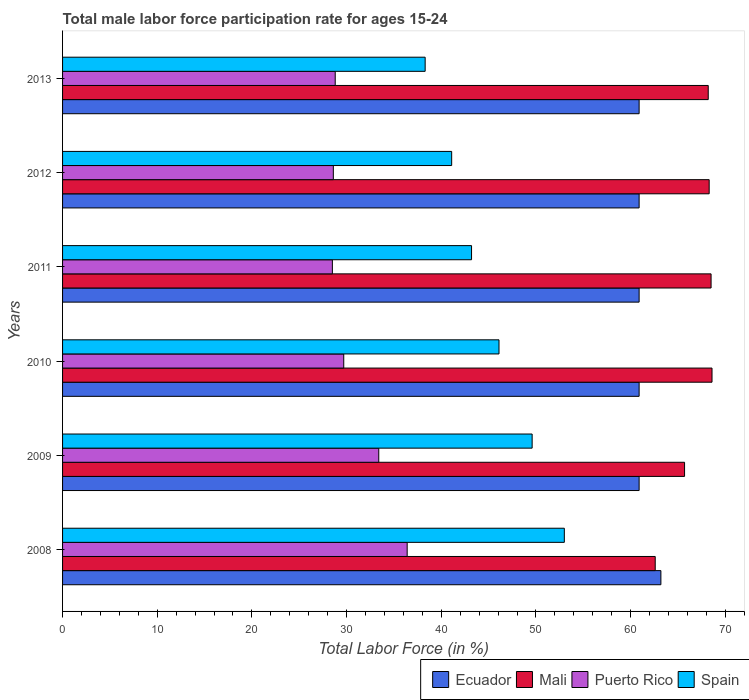How many different coloured bars are there?
Make the answer very short. 4. What is the male labor force participation rate in Spain in 2010?
Your answer should be very brief. 46.1. Across all years, what is the maximum male labor force participation rate in Ecuador?
Make the answer very short. 63.2. Across all years, what is the minimum male labor force participation rate in Ecuador?
Keep it short and to the point. 60.9. In which year was the male labor force participation rate in Mali minimum?
Keep it short and to the point. 2008. What is the total male labor force participation rate in Mali in the graph?
Your answer should be very brief. 401.9. What is the difference between the male labor force participation rate in Mali in 2012 and that in 2013?
Offer a terse response. 0.1. What is the difference between the male labor force participation rate in Puerto Rico in 2009 and the male labor force participation rate in Mali in 2012?
Your answer should be compact. -34.9. What is the average male labor force participation rate in Ecuador per year?
Give a very brief answer. 61.28. In the year 2013, what is the difference between the male labor force participation rate in Puerto Rico and male labor force participation rate in Mali?
Your answer should be compact. -39.4. In how many years, is the male labor force participation rate in Spain greater than 20 %?
Ensure brevity in your answer.  6. What is the ratio of the male labor force participation rate in Spain in 2008 to that in 2013?
Provide a succinct answer. 1.38. Is the difference between the male labor force participation rate in Puerto Rico in 2011 and 2012 greater than the difference between the male labor force participation rate in Mali in 2011 and 2012?
Offer a terse response. No. What is the difference between the highest and the second highest male labor force participation rate in Ecuador?
Provide a short and direct response. 2.3. What is the difference between the highest and the lowest male labor force participation rate in Mali?
Ensure brevity in your answer.  6. In how many years, is the male labor force participation rate in Spain greater than the average male labor force participation rate in Spain taken over all years?
Your response must be concise. 3. Is the sum of the male labor force participation rate in Spain in 2011 and 2013 greater than the maximum male labor force participation rate in Puerto Rico across all years?
Your response must be concise. Yes. What does the 2nd bar from the top in 2013 represents?
Make the answer very short. Puerto Rico. What does the 3rd bar from the bottom in 2010 represents?
Your answer should be very brief. Puerto Rico. How many bars are there?
Your answer should be compact. 24. How many years are there in the graph?
Keep it short and to the point. 6. Are the values on the major ticks of X-axis written in scientific E-notation?
Ensure brevity in your answer.  No. Does the graph contain any zero values?
Your answer should be very brief. No. Where does the legend appear in the graph?
Ensure brevity in your answer.  Bottom right. How many legend labels are there?
Your response must be concise. 4. How are the legend labels stacked?
Give a very brief answer. Horizontal. What is the title of the graph?
Offer a very short reply. Total male labor force participation rate for ages 15-24. What is the label or title of the X-axis?
Make the answer very short. Total Labor Force (in %). What is the label or title of the Y-axis?
Provide a succinct answer. Years. What is the Total Labor Force (in %) in Ecuador in 2008?
Your answer should be very brief. 63.2. What is the Total Labor Force (in %) in Mali in 2008?
Offer a very short reply. 62.6. What is the Total Labor Force (in %) in Puerto Rico in 2008?
Offer a very short reply. 36.4. What is the Total Labor Force (in %) of Ecuador in 2009?
Make the answer very short. 60.9. What is the Total Labor Force (in %) of Mali in 2009?
Your answer should be compact. 65.7. What is the Total Labor Force (in %) of Puerto Rico in 2009?
Offer a very short reply. 33.4. What is the Total Labor Force (in %) in Spain in 2009?
Your response must be concise. 49.6. What is the Total Labor Force (in %) in Ecuador in 2010?
Offer a very short reply. 60.9. What is the Total Labor Force (in %) of Mali in 2010?
Give a very brief answer. 68.6. What is the Total Labor Force (in %) in Puerto Rico in 2010?
Keep it short and to the point. 29.7. What is the Total Labor Force (in %) of Spain in 2010?
Provide a short and direct response. 46.1. What is the Total Labor Force (in %) of Ecuador in 2011?
Give a very brief answer. 60.9. What is the Total Labor Force (in %) in Mali in 2011?
Make the answer very short. 68.5. What is the Total Labor Force (in %) of Spain in 2011?
Provide a succinct answer. 43.2. What is the Total Labor Force (in %) in Ecuador in 2012?
Provide a short and direct response. 60.9. What is the Total Labor Force (in %) in Mali in 2012?
Make the answer very short. 68.3. What is the Total Labor Force (in %) in Puerto Rico in 2012?
Offer a terse response. 28.6. What is the Total Labor Force (in %) of Spain in 2012?
Offer a terse response. 41.1. What is the Total Labor Force (in %) in Ecuador in 2013?
Keep it short and to the point. 60.9. What is the Total Labor Force (in %) of Mali in 2013?
Provide a succinct answer. 68.2. What is the Total Labor Force (in %) in Puerto Rico in 2013?
Offer a very short reply. 28.8. What is the Total Labor Force (in %) in Spain in 2013?
Offer a terse response. 38.3. Across all years, what is the maximum Total Labor Force (in %) in Ecuador?
Keep it short and to the point. 63.2. Across all years, what is the maximum Total Labor Force (in %) of Mali?
Your answer should be compact. 68.6. Across all years, what is the maximum Total Labor Force (in %) of Puerto Rico?
Your response must be concise. 36.4. Across all years, what is the minimum Total Labor Force (in %) in Ecuador?
Give a very brief answer. 60.9. Across all years, what is the minimum Total Labor Force (in %) of Mali?
Offer a terse response. 62.6. Across all years, what is the minimum Total Labor Force (in %) of Spain?
Make the answer very short. 38.3. What is the total Total Labor Force (in %) in Ecuador in the graph?
Offer a very short reply. 367.7. What is the total Total Labor Force (in %) in Mali in the graph?
Provide a short and direct response. 401.9. What is the total Total Labor Force (in %) in Puerto Rico in the graph?
Provide a short and direct response. 185.4. What is the total Total Labor Force (in %) of Spain in the graph?
Make the answer very short. 271.3. What is the difference between the Total Labor Force (in %) of Ecuador in 2008 and that in 2009?
Ensure brevity in your answer.  2.3. What is the difference between the Total Labor Force (in %) of Spain in 2008 and that in 2009?
Keep it short and to the point. 3.4. What is the difference between the Total Labor Force (in %) of Puerto Rico in 2008 and that in 2010?
Your response must be concise. 6.7. What is the difference between the Total Labor Force (in %) of Spain in 2008 and that in 2010?
Your answer should be very brief. 6.9. What is the difference between the Total Labor Force (in %) in Puerto Rico in 2008 and that in 2011?
Offer a terse response. 7.9. What is the difference between the Total Labor Force (in %) in Spain in 2008 and that in 2011?
Offer a terse response. 9.8. What is the difference between the Total Labor Force (in %) of Spain in 2008 and that in 2012?
Your answer should be compact. 11.9. What is the difference between the Total Labor Force (in %) in Ecuador in 2008 and that in 2013?
Offer a terse response. 2.3. What is the difference between the Total Labor Force (in %) of Mali in 2008 and that in 2013?
Provide a short and direct response. -5.6. What is the difference between the Total Labor Force (in %) in Spain in 2008 and that in 2013?
Your response must be concise. 14.7. What is the difference between the Total Labor Force (in %) in Puerto Rico in 2009 and that in 2010?
Ensure brevity in your answer.  3.7. What is the difference between the Total Labor Force (in %) in Ecuador in 2009 and that in 2011?
Ensure brevity in your answer.  0. What is the difference between the Total Labor Force (in %) of Puerto Rico in 2009 and that in 2011?
Your answer should be very brief. 4.9. What is the difference between the Total Labor Force (in %) in Spain in 2009 and that in 2011?
Make the answer very short. 6.4. What is the difference between the Total Labor Force (in %) in Mali in 2009 and that in 2012?
Your answer should be compact. -2.6. What is the difference between the Total Labor Force (in %) of Puerto Rico in 2009 and that in 2012?
Offer a terse response. 4.8. What is the difference between the Total Labor Force (in %) in Ecuador in 2010 and that in 2011?
Your response must be concise. 0. What is the difference between the Total Labor Force (in %) in Ecuador in 2010 and that in 2012?
Make the answer very short. 0. What is the difference between the Total Labor Force (in %) in Mali in 2010 and that in 2012?
Make the answer very short. 0.3. What is the difference between the Total Labor Force (in %) in Spain in 2010 and that in 2012?
Keep it short and to the point. 5. What is the difference between the Total Labor Force (in %) of Mali in 2010 and that in 2013?
Keep it short and to the point. 0.4. What is the difference between the Total Labor Force (in %) of Spain in 2010 and that in 2013?
Your answer should be very brief. 7.8. What is the difference between the Total Labor Force (in %) of Ecuador in 2011 and that in 2012?
Ensure brevity in your answer.  0. What is the difference between the Total Labor Force (in %) in Mali in 2011 and that in 2012?
Offer a terse response. 0.2. What is the difference between the Total Labor Force (in %) in Puerto Rico in 2011 and that in 2012?
Offer a very short reply. -0.1. What is the difference between the Total Labor Force (in %) of Puerto Rico in 2011 and that in 2013?
Provide a short and direct response. -0.3. What is the difference between the Total Labor Force (in %) of Mali in 2012 and that in 2013?
Provide a short and direct response. 0.1. What is the difference between the Total Labor Force (in %) of Puerto Rico in 2012 and that in 2013?
Keep it short and to the point. -0.2. What is the difference between the Total Labor Force (in %) of Spain in 2012 and that in 2013?
Your answer should be compact. 2.8. What is the difference between the Total Labor Force (in %) in Ecuador in 2008 and the Total Labor Force (in %) in Puerto Rico in 2009?
Your response must be concise. 29.8. What is the difference between the Total Labor Force (in %) of Ecuador in 2008 and the Total Labor Force (in %) of Spain in 2009?
Provide a short and direct response. 13.6. What is the difference between the Total Labor Force (in %) in Mali in 2008 and the Total Labor Force (in %) in Puerto Rico in 2009?
Provide a succinct answer. 29.2. What is the difference between the Total Labor Force (in %) of Mali in 2008 and the Total Labor Force (in %) of Spain in 2009?
Provide a succinct answer. 13. What is the difference between the Total Labor Force (in %) of Ecuador in 2008 and the Total Labor Force (in %) of Puerto Rico in 2010?
Provide a succinct answer. 33.5. What is the difference between the Total Labor Force (in %) in Ecuador in 2008 and the Total Labor Force (in %) in Spain in 2010?
Offer a very short reply. 17.1. What is the difference between the Total Labor Force (in %) in Mali in 2008 and the Total Labor Force (in %) in Puerto Rico in 2010?
Offer a terse response. 32.9. What is the difference between the Total Labor Force (in %) in Mali in 2008 and the Total Labor Force (in %) in Spain in 2010?
Your response must be concise. 16.5. What is the difference between the Total Labor Force (in %) of Ecuador in 2008 and the Total Labor Force (in %) of Mali in 2011?
Your response must be concise. -5.3. What is the difference between the Total Labor Force (in %) in Ecuador in 2008 and the Total Labor Force (in %) in Puerto Rico in 2011?
Your response must be concise. 34.7. What is the difference between the Total Labor Force (in %) of Mali in 2008 and the Total Labor Force (in %) of Puerto Rico in 2011?
Your answer should be very brief. 34.1. What is the difference between the Total Labor Force (in %) of Mali in 2008 and the Total Labor Force (in %) of Spain in 2011?
Give a very brief answer. 19.4. What is the difference between the Total Labor Force (in %) of Ecuador in 2008 and the Total Labor Force (in %) of Puerto Rico in 2012?
Your answer should be compact. 34.6. What is the difference between the Total Labor Force (in %) in Ecuador in 2008 and the Total Labor Force (in %) in Spain in 2012?
Make the answer very short. 22.1. What is the difference between the Total Labor Force (in %) of Ecuador in 2008 and the Total Labor Force (in %) of Mali in 2013?
Your answer should be compact. -5. What is the difference between the Total Labor Force (in %) in Ecuador in 2008 and the Total Labor Force (in %) in Puerto Rico in 2013?
Make the answer very short. 34.4. What is the difference between the Total Labor Force (in %) in Ecuador in 2008 and the Total Labor Force (in %) in Spain in 2013?
Offer a terse response. 24.9. What is the difference between the Total Labor Force (in %) of Mali in 2008 and the Total Labor Force (in %) of Puerto Rico in 2013?
Provide a succinct answer. 33.8. What is the difference between the Total Labor Force (in %) in Mali in 2008 and the Total Labor Force (in %) in Spain in 2013?
Make the answer very short. 24.3. What is the difference between the Total Labor Force (in %) in Puerto Rico in 2008 and the Total Labor Force (in %) in Spain in 2013?
Give a very brief answer. -1.9. What is the difference between the Total Labor Force (in %) of Ecuador in 2009 and the Total Labor Force (in %) of Mali in 2010?
Give a very brief answer. -7.7. What is the difference between the Total Labor Force (in %) of Ecuador in 2009 and the Total Labor Force (in %) of Puerto Rico in 2010?
Offer a very short reply. 31.2. What is the difference between the Total Labor Force (in %) of Ecuador in 2009 and the Total Labor Force (in %) of Spain in 2010?
Provide a succinct answer. 14.8. What is the difference between the Total Labor Force (in %) in Mali in 2009 and the Total Labor Force (in %) in Puerto Rico in 2010?
Provide a short and direct response. 36. What is the difference between the Total Labor Force (in %) of Mali in 2009 and the Total Labor Force (in %) of Spain in 2010?
Provide a succinct answer. 19.6. What is the difference between the Total Labor Force (in %) of Puerto Rico in 2009 and the Total Labor Force (in %) of Spain in 2010?
Provide a short and direct response. -12.7. What is the difference between the Total Labor Force (in %) in Ecuador in 2009 and the Total Labor Force (in %) in Puerto Rico in 2011?
Provide a succinct answer. 32.4. What is the difference between the Total Labor Force (in %) in Ecuador in 2009 and the Total Labor Force (in %) in Spain in 2011?
Your answer should be very brief. 17.7. What is the difference between the Total Labor Force (in %) of Mali in 2009 and the Total Labor Force (in %) of Puerto Rico in 2011?
Your answer should be very brief. 37.2. What is the difference between the Total Labor Force (in %) in Mali in 2009 and the Total Labor Force (in %) in Spain in 2011?
Keep it short and to the point. 22.5. What is the difference between the Total Labor Force (in %) of Ecuador in 2009 and the Total Labor Force (in %) of Puerto Rico in 2012?
Your response must be concise. 32.3. What is the difference between the Total Labor Force (in %) in Ecuador in 2009 and the Total Labor Force (in %) in Spain in 2012?
Offer a very short reply. 19.8. What is the difference between the Total Labor Force (in %) of Mali in 2009 and the Total Labor Force (in %) of Puerto Rico in 2012?
Provide a succinct answer. 37.1. What is the difference between the Total Labor Force (in %) of Mali in 2009 and the Total Labor Force (in %) of Spain in 2012?
Offer a terse response. 24.6. What is the difference between the Total Labor Force (in %) in Puerto Rico in 2009 and the Total Labor Force (in %) in Spain in 2012?
Your answer should be compact. -7.7. What is the difference between the Total Labor Force (in %) in Ecuador in 2009 and the Total Labor Force (in %) in Puerto Rico in 2013?
Keep it short and to the point. 32.1. What is the difference between the Total Labor Force (in %) in Ecuador in 2009 and the Total Labor Force (in %) in Spain in 2013?
Offer a terse response. 22.6. What is the difference between the Total Labor Force (in %) of Mali in 2009 and the Total Labor Force (in %) of Puerto Rico in 2013?
Your answer should be very brief. 36.9. What is the difference between the Total Labor Force (in %) of Mali in 2009 and the Total Labor Force (in %) of Spain in 2013?
Give a very brief answer. 27.4. What is the difference between the Total Labor Force (in %) in Ecuador in 2010 and the Total Labor Force (in %) in Puerto Rico in 2011?
Give a very brief answer. 32.4. What is the difference between the Total Labor Force (in %) in Ecuador in 2010 and the Total Labor Force (in %) in Spain in 2011?
Keep it short and to the point. 17.7. What is the difference between the Total Labor Force (in %) in Mali in 2010 and the Total Labor Force (in %) in Puerto Rico in 2011?
Give a very brief answer. 40.1. What is the difference between the Total Labor Force (in %) in Mali in 2010 and the Total Labor Force (in %) in Spain in 2011?
Your answer should be compact. 25.4. What is the difference between the Total Labor Force (in %) in Puerto Rico in 2010 and the Total Labor Force (in %) in Spain in 2011?
Keep it short and to the point. -13.5. What is the difference between the Total Labor Force (in %) of Ecuador in 2010 and the Total Labor Force (in %) of Puerto Rico in 2012?
Provide a short and direct response. 32.3. What is the difference between the Total Labor Force (in %) of Ecuador in 2010 and the Total Labor Force (in %) of Spain in 2012?
Make the answer very short. 19.8. What is the difference between the Total Labor Force (in %) in Mali in 2010 and the Total Labor Force (in %) in Spain in 2012?
Keep it short and to the point. 27.5. What is the difference between the Total Labor Force (in %) in Puerto Rico in 2010 and the Total Labor Force (in %) in Spain in 2012?
Give a very brief answer. -11.4. What is the difference between the Total Labor Force (in %) of Ecuador in 2010 and the Total Labor Force (in %) of Mali in 2013?
Offer a very short reply. -7.3. What is the difference between the Total Labor Force (in %) of Ecuador in 2010 and the Total Labor Force (in %) of Puerto Rico in 2013?
Your response must be concise. 32.1. What is the difference between the Total Labor Force (in %) in Ecuador in 2010 and the Total Labor Force (in %) in Spain in 2013?
Keep it short and to the point. 22.6. What is the difference between the Total Labor Force (in %) in Mali in 2010 and the Total Labor Force (in %) in Puerto Rico in 2013?
Keep it short and to the point. 39.8. What is the difference between the Total Labor Force (in %) of Mali in 2010 and the Total Labor Force (in %) of Spain in 2013?
Your answer should be compact. 30.3. What is the difference between the Total Labor Force (in %) of Puerto Rico in 2010 and the Total Labor Force (in %) of Spain in 2013?
Keep it short and to the point. -8.6. What is the difference between the Total Labor Force (in %) of Ecuador in 2011 and the Total Labor Force (in %) of Mali in 2012?
Give a very brief answer. -7.4. What is the difference between the Total Labor Force (in %) of Ecuador in 2011 and the Total Labor Force (in %) of Puerto Rico in 2012?
Your answer should be very brief. 32.3. What is the difference between the Total Labor Force (in %) in Ecuador in 2011 and the Total Labor Force (in %) in Spain in 2012?
Offer a terse response. 19.8. What is the difference between the Total Labor Force (in %) in Mali in 2011 and the Total Labor Force (in %) in Puerto Rico in 2012?
Ensure brevity in your answer.  39.9. What is the difference between the Total Labor Force (in %) of Mali in 2011 and the Total Labor Force (in %) of Spain in 2012?
Make the answer very short. 27.4. What is the difference between the Total Labor Force (in %) in Ecuador in 2011 and the Total Labor Force (in %) in Puerto Rico in 2013?
Provide a short and direct response. 32.1. What is the difference between the Total Labor Force (in %) in Ecuador in 2011 and the Total Labor Force (in %) in Spain in 2013?
Offer a very short reply. 22.6. What is the difference between the Total Labor Force (in %) of Mali in 2011 and the Total Labor Force (in %) of Puerto Rico in 2013?
Ensure brevity in your answer.  39.7. What is the difference between the Total Labor Force (in %) of Mali in 2011 and the Total Labor Force (in %) of Spain in 2013?
Keep it short and to the point. 30.2. What is the difference between the Total Labor Force (in %) of Ecuador in 2012 and the Total Labor Force (in %) of Mali in 2013?
Your answer should be very brief. -7.3. What is the difference between the Total Labor Force (in %) of Ecuador in 2012 and the Total Labor Force (in %) of Puerto Rico in 2013?
Ensure brevity in your answer.  32.1. What is the difference between the Total Labor Force (in %) in Ecuador in 2012 and the Total Labor Force (in %) in Spain in 2013?
Keep it short and to the point. 22.6. What is the difference between the Total Labor Force (in %) in Mali in 2012 and the Total Labor Force (in %) in Puerto Rico in 2013?
Ensure brevity in your answer.  39.5. What is the difference between the Total Labor Force (in %) of Mali in 2012 and the Total Labor Force (in %) of Spain in 2013?
Your answer should be very brief. 30. What is the difference between the Total Labor Force (in %) of Puerto Rico in 2012 and the Total Labor Force (in %) of Spain in 2013?
Give a very brief answer. -9.7. What is the average Total Labor Force (in %) of Ecuador per year?
Your answer should be compact. 61.28. What is the average Total Labor Force (in %) in Mali per year?
Offer a terse response. 66.98. What is the average Total Labor Force (in %) in Puerto Rico per year?
Your answer should be compact. 30.9. What is the average Total Labor Force (in %) of Spain per year?
Offer a terse response. 45.22. In the year 2008, what is the difference between the Total Labor Force (in %) in Ecuador and Total Labor Force (in %) in Mali?
Keep it short and to the point. 0.6. In the year 2008, what is the difference between the Total Labor Force (in %) in Ecuador and Total Labor Force (in %) in Puerto Rico?
Give a very brief answer. 26.8. In the year 2008, what is the difference between the Total Labor Force (in %) in Ecuador and Total Labor Force (in %) in Spain?
Your answer should be compact. 10.2. In the year 2008, what is the difference between the Total Labor Force (in %) in Mali and Total Labor Force (in %) in Puerto Rico?
Your answer should be compact. 26.2. In the year 2008, what is the difference between the Total Labor Force (in %) in Puerto Rico and Total Labor Force (in %) in Spain?
Your answer should be compact. -16.6. In the year 2009, what is the difference between the Total Labor Force (in %) in Mali and Total Labor Force (in %) in Puerto Rico?
Ensure brevity in your answer.  32.3. In the year 2009, what is the difference between the Total Labor Force (in %) of Puerto Rico and Total Labor Force (in %) of Spain?
Offer a very short reply. -16.2. In the year 2010, what is the difference between the Total Labor Force (in %) of Ecuador and Total Labor Force (in %) of Puerto Rico?
Your answer should be very brief. 31.2. In the year 2010, what is the difference between the Total Labor Force (in %) in Ecuador and Total Labor Force (in %) in Spain?
Keep it short and to the point. 14.8. In the year 2010, what is the difference between the Total Labor Force (in %) of Mali and Total Labor Force (in %) of Puerto Rico?
Your answer should be compact. 38.9. In the year 2010, what is the difference between the Total Labor Force (in %) of Mali and Total Labor Force (in %) of Spain?
Make the answer very short. 22.5. In the year 2010, what is the difference between the Total Labor Force (in %) in Puerto Rico and Total Labor Force (in %) in Spain?
Make the answer very short. -16.4. In the year 2011, what is the difference between the Total Labor Force (in %) of Ecuador and Total Labor Force (in %) of Puerto Rico?
Ensure brevity in your answer.  32.4. In the year 2011, what is the difference between the Total Labor Force (in %) of Ecuador and Total Labor Force (in %) of Spain?
Provide a short and direct response. 17.7. In the year 2011, what is the difference between the Total Labor Force (in %) of Mali and Total Labor Force (in %) of Puerto Rico?
Your answer should be compact. 40. In the year 2011, what is the difference between the Total Labor Force (in %) of Mali and Total Labor Force (in %) of Spain?
Your answer should be very brief. 25.3. In the year 2011, what is the difference between the Total Labor Force (in %) in Puerto Rico and Total Labor Force (in %) in Spain?
Keep it short and to the point. -14.7. In the year 2012, what is the difference between the Total Labor Force (in %) in Ecuador and Total Labor Force (in %) in Mali?
Ensure brevity in your answer.  -7.4. In the year 2012, what is the difference between the Total Labor Force (in %) of Ecuador and Total Labor Force (in %) of Puerto Rico?
Ensure brevity in your answer.  32.3. In the year 2012, what is the difference between the Total Labor Force (in %) of Ecuador and Total Labor Force (in %) of Spain?
Provide a short and direct response. 19.8. In the year 2012, what is the difference between the Total Labor Force (in %) of Mali and Total Labor Force (in %) of Puerto Rico?
Your answer should be compact. 39.7. In the year 2012, what is the difference between the Total Labor Force (in %) of Mali and Total Labor Force (in %) of Spain?
Ensure brevity in your answer.  27.2. In the year 2012, what is the difference between the Total Labor Force (in %) of Puerto Rico and Total Labor Force (in %) of Spain?
Provide a short and direct response. -12.5. In the year 2013, what is the difference between the Total Labor Force (in %) of Ecuador and Total Labor Force (in %) of Mali?
Give a very brief answer. -7.3. In the year 2013, what is the difference between the Total Labor Force (in %) in Ecuador and Total Labor Force (in %) in Puerto Rico?
Give a very brief answer. 32.1. In the year 2013, what is the difference between the Total Labor Force (in %) of Ecuador and Total Labor Force (in %) of Spain?
Ensure brevity in your answer.  22.6. In the year 2013, what is the difference between the Total Labor Force (in %) in Mali and Total Labor Force (in %) in Puerto Rico?
Ensure brevity in your answer.  39.4. In the year 2013, what is the difference between the Total Labor Force (in %) in Mali and Total Labor Force (in %) in Spain?
Your response must be concise. 29.9. In the year 2013, what is the difference between the Total Labor Force (in %) of Puerto Rico and Total Labor Force (in %) of Spain?
Make the answer very short. -9.5. What is the ratio of the Total Labor Force (in %) in Ecuador in 2008 to that in 2009?
Offer a very short reply. 1.04. What is the ratio of the Total Labor Force (in %) of Mali in 2008 to that in 2009?
Ensure brevity in your answer.  0.95. What is the ratio of the Total Labor Force (in %) in Puerto Rico in 2008 to that in 2009?
Ensure brevity in your answer.  1.09. What is the ratio of the Total Labor Force (in %) in Spain in 2008 to that in 2009?
Your answer should be compact. 1.07. What is the ratio of the Total Labor Force (in %) of Ecuador in 2008 to that in 2010?
Your answer should be compact. 1.04. What is the ratio of the Total Labor Force (in %) in Mali in 2008 to that in 2010?
Give a very brief answer. 0.91. What is the ratio of the Total Labor Force (in %) of Puerto Rico in 2008 to that in 2010?
Make the answer very short. 1.23. What is the ratio of the Total Labor Force (in %) in Spain in 2008 to that in 2010?
Keep it short and to the point. 1.15. What is the ratio of the Total Labor Force (in %) of Ecuador in 2008 to that in 2011?
Provide a succinct answer. 1.04. What is the ratio of the Total Labor Force (in %) of Mali in 2008 to that in 2011?
Provide a succinct answer. 0.91. What is the ratio of the Total Labor Force (in %) of Puerto Rico in 2008 to that in 2011?
Ensure brevity in your answer.  1.28. What is the ratio of the Total Labor Force (in %) of Spain in 2008 to that in 2011?
Your response must be concise. 1.23. What is the ratio of the Total Labor Force (in %) of Ecuador in 2008 to that in 2012?
Offer a very short reply. 1.04. What is the ratio of the Total Labor Force (in %) of Mali in 2008 to that in 2012?
Provide a short and direct response. 0.92. What is the ratio of the Total Labor Force (in %) of Puerto Rico in 2008 to that in 2012?
Offer a very short reply. 1.27. What is the ratio of the Total Labor Force (in %) in Spain in 2008 to that in 2012?
Offer a terse response. 1.29. What is the ratio of the Total Labor Force (in %) in Ecuador in 2008 to that in 2013?
Give a very brief answer. 1.04. What is the ratio of the Total Labor Force (in %) in Mali in 2008 to that in 2013?
Give a very brief answer. 0.92. What is the ratio of the Total Labor Force (in %) in Puerto Rico in 2008 to that in 2013?
Ensure brevity in your answer.  1.26. What is the ratio of the Total Labor Force (in %) in Spain in 2008 to that in 2013?
Your answer should be compact. 1.38. What is the ratio of the Total Labor Force (in %) of Ecuador in 2009 to that in 2010?
Give a very brief answer. 1. What is the ratio of the Total Labor Force (in %) of Mali in 2009 to that in 2010?
Offer a very short reply. 0.96. What is the ratio of the Total Labor Force (in %) of Puerto Rico in 2009 to that in 2010?
Your response must be concise. 1.12. What is the ratio of the Total Labor Force (in %) in Spain in 2009 to that in 2010?
Provide a succinct answer. 1.08. What is the ratio of the Total Labor Force (in %) in Ecuador in 2009 to that in 2011?
Give a very brief answer. 1. What is the ratio of the Total Labor Force (in %) in Mali in 2009 to that in 2011?
Your response must be concise. 0.96. What is the ratio of the Total Labor Force (in %) in Puerto Rico in 2009 to that in 2011?
Offer a terse response. 1.17. What is the ratio of the Total Labor Force (in %) of Spain in 2009 to that in 2011?
Make the answer very short. 1.15. What is the ratio of the Total Labor Force (in %) in Ecuador in 2009 to that in 2012?
Offer a very short reply. 1. What is the ratio of the Total Labor Force (in %) in Mali in 2009 to that in 2012?
Your response must be concise. 0.96. What is the ratio of the Total Labor Force (in %) of Puerto Rico in 2009 to that in 2012?
Offer a very short reply. 1.17. What is the ratio of the Total Labor Force (in %) in Spain in 2009 to that in 2012?
Your answer should be compact. 1.21. What is the ratio of the Total Labor Force (in %) in Ecuador in 2009 to that in 2013?
Your response must be concise. 1. What is the ratio of the Total Labor Force (in %) of Mali in 2009 to that in 2013?
Your answer should be compact. 0.96. What is the ratio of the Total Labor Force (in %) of Puerto Rico in 2009 to that in 2013?
Provide a short and direct response. 1.16. What is the ratio of the Total Labor Force (in %) in Spain in 2009 to that in 2013?
Ensure brevity in your answer.  1.29. What is the ratio of the Total Labor Force (in %) in Mali in 2010 to that in 2011?
Provide a succinct answer. 1. What is the ratio of the Total Labor Force (in %) of Puerto Rico in 2010 to that in 2011?
Ensure brevity in your answer.  1.04. What is the ratio of the Total Labor Force (in %) in Spain in 2010 to that in 2011?
Provide a short and direct response. 1.07. What is the ratio of the Total Labor Force (in %) in Mali in 2010 to that in 2012?
Your answer should be very brief. 1. What is the ratio of the Total Labor Force (in %) of Puerto Rico in 2010 to that in 2012?
Your response must be concise. 1.04. What is the ratio of the Total Labor Force (in %) in Spain in 2010 to that in 2012?
Ensure brevity in your answer.  1.12. What is the ratio of the Total Labor Force (in %) in Mali in 2010 to that in 2013?
Provide a short and direct response. 1.01. What is the ratio of the Total Labor Force (in %) in Puerto Rico in 2010 to that in 2013?
Keep it short and to the point. 1.03. What is the ratio of the Total Labor Force (in %) in Spain in 2010 to that in 2013?
Give a very brief answer. 1.2. What is the ratio of the Total Labor Force (in %) of Mali in 2011 to that in 2012?
Make the answer very short. 1. What is the ratio of the Total Labor Force (in %) of Spain in 2011 to that in 2012?
Give a very brief answer. 1.05. What is the ratio of the Total Labor Force (in %) of Ecuador in 2011 to that in 2013?
Give a very brief answer. 1. What is the ratio of the Total Labor Force (in %) in Spain in 2011 to that in 2013?
Offer a very short reply. 1.13. What is the ratio of the Total Labor Force (in %) in Ecuador in 2012 to that in 2013?
Keep it short and to the point. 1. What is the ratio of the Total Labor Force (in %) in Mali in 2012 to that in 2013?
Make the answer very short. 1. What is the ratio of the Total Labor Force (in %) of Spain in 2012 to that in 2013?
Give a very brief answer. 1.07. What is the difference between the highest and the second highest Total Labor Force (in %) of Mali?
Make the answer very short. 0.1. What is the difference between the highest and the lowest Total Labor Force (in %) in Ecuador?
Provide a short and direct response. 2.3. What is the difference between the highest and the lowest Total Labor Force (in %) of Puerto Rico?
Keep it short and to the point. 7.9. 